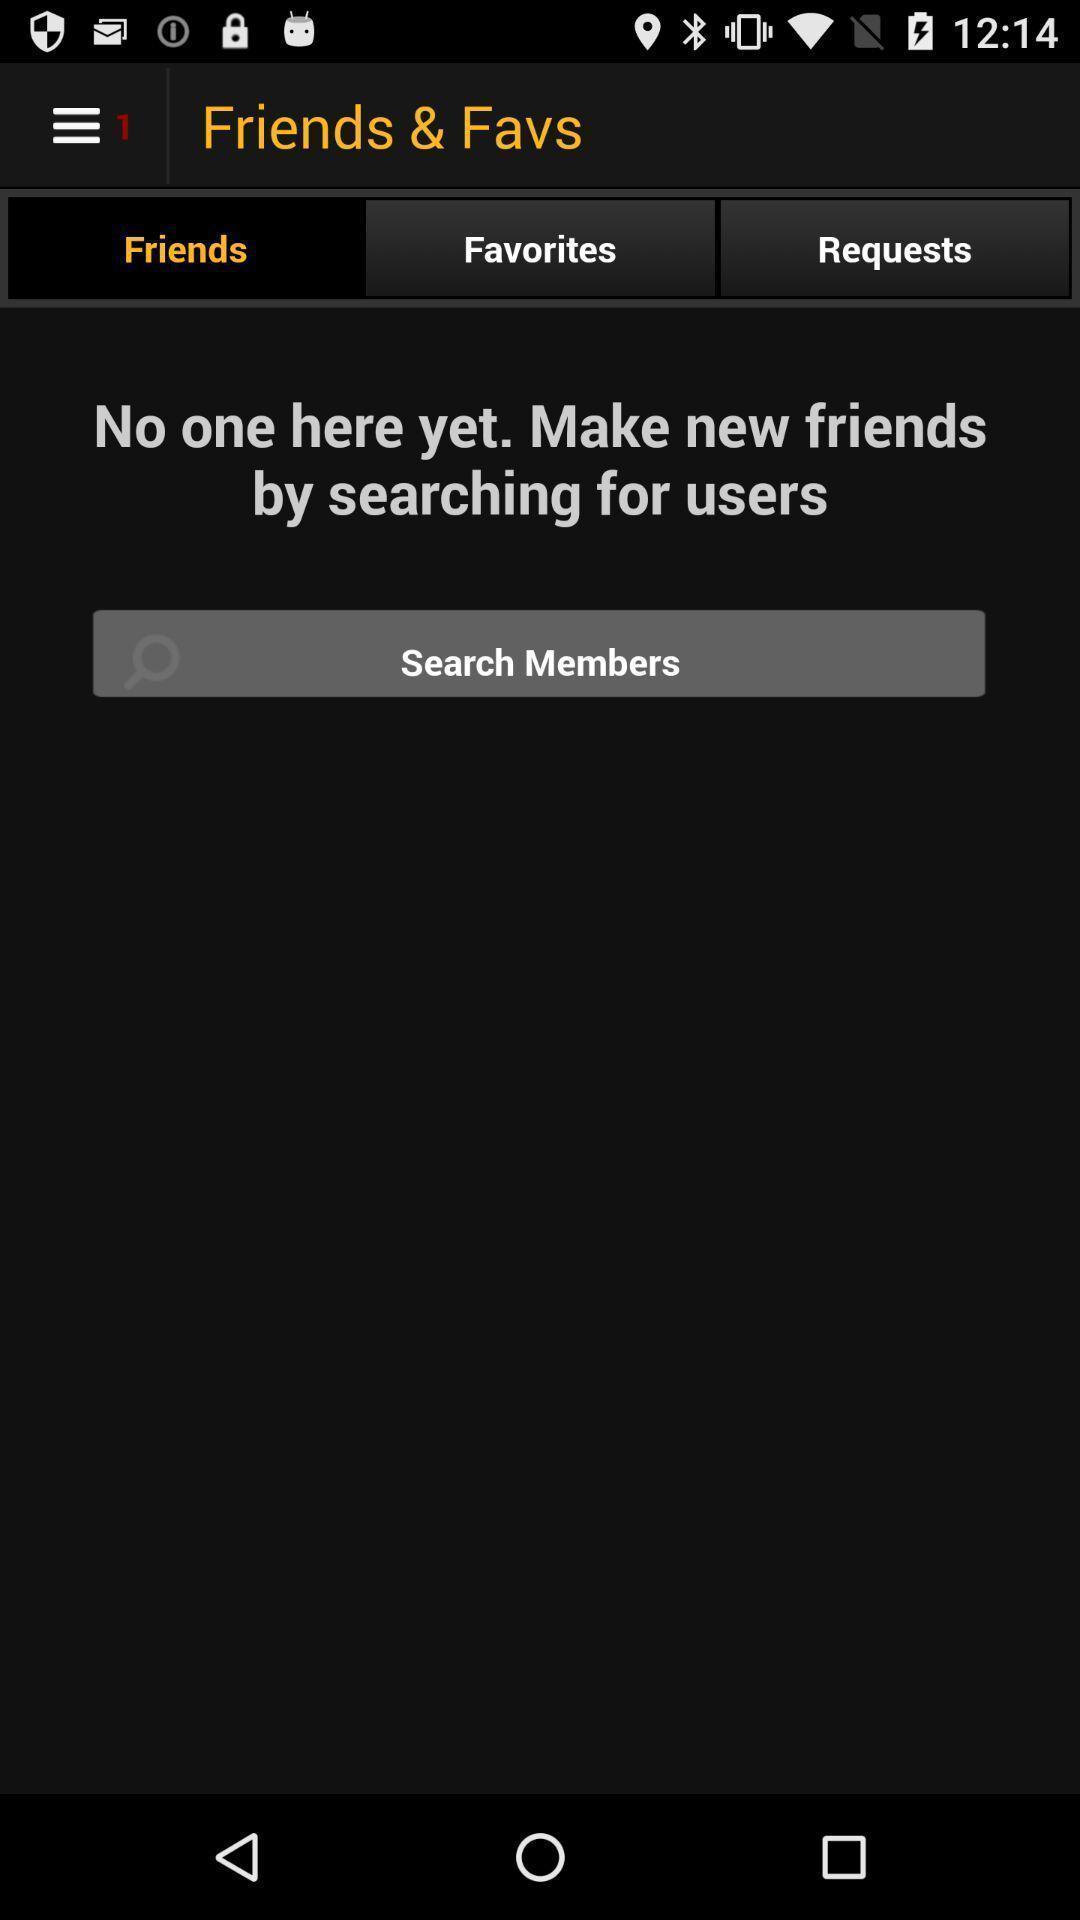Please provide a description for this image. Search page for the social app. 